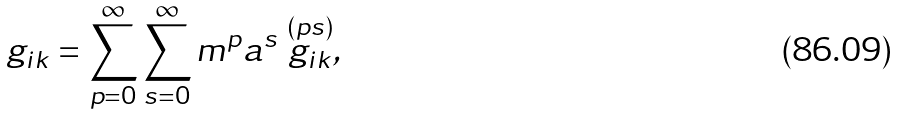Convert formula to latex. <formula><loc_0><loc_0><loc_500><loc_500>g _ { i k } = \sum _ { p = 0 } ^ { \infty } \sum _ { s = 0 } ^ { \infty } m ^ { p } a ^ { s } \stackrel { ( p s ) } { g _ { i k } } ,</formula> 